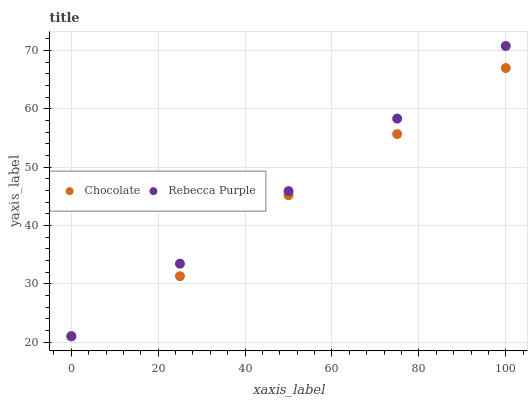Does Chocolate have the minimum area under the curve?
Answer yes or no. Yes. Does Rebecca Purple have the maximum area under the curve?
Answer yes or no. Yes. Does Chocolate have the maximum area under the curve?
Answer yes or no. No. Is Rebecca Purple the smoothest?
Answer yes or no. Yes. Is Chocolate the roughest?
Answer yes or no. Yes. Is Chocolate the smoothest?
Answer yes or no. No. Does Rebecca Purple have the lowest value?
Answer yes or no. Yes. Does Rebecca Purple have the highest value?
Answer yes or no. Yes. Does Chocolate have the highest value?
Answer yes or no. No. Does Rebecca Purple intersect Chocolate?
Answer yes or no. Yes. Is Rebecca Purple less than Chocolate?
Answer yes or no. No. Is Rebecca Purple greater than Chocolate?
Answer yes or no. No. 